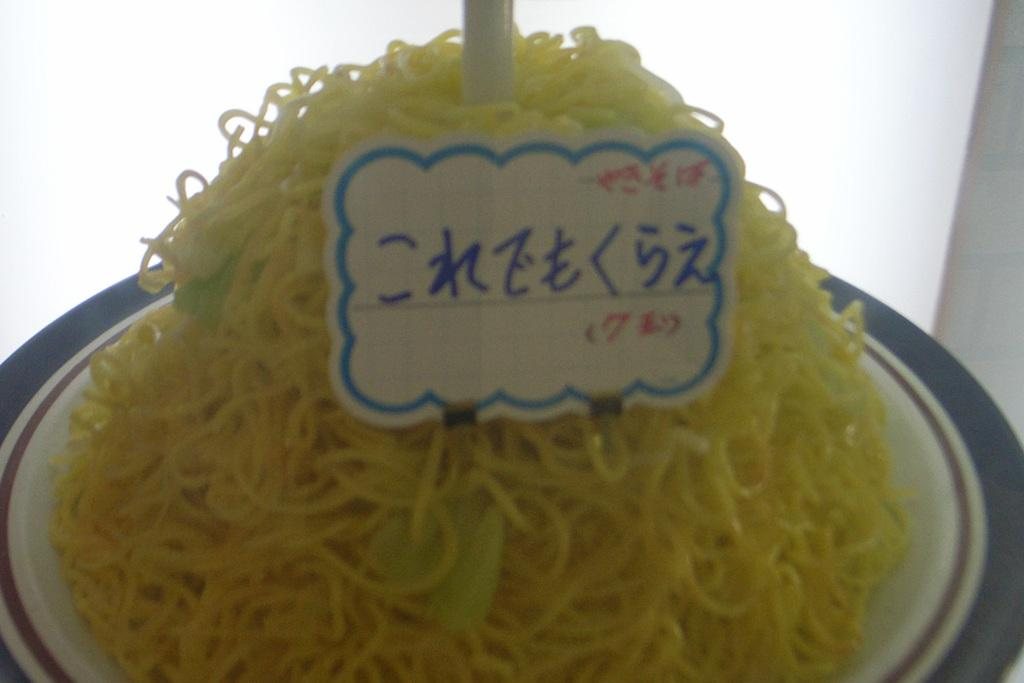What is on the plate that is visible in the image? The plate contains noodles. What else can be seen in the image besides the plate and noodles? There is a sticker with text on it in the image. What advice does the dad give to the police in the image? There is no dad or police present in the image; it only features a plate of noodles and a sticker with text. 